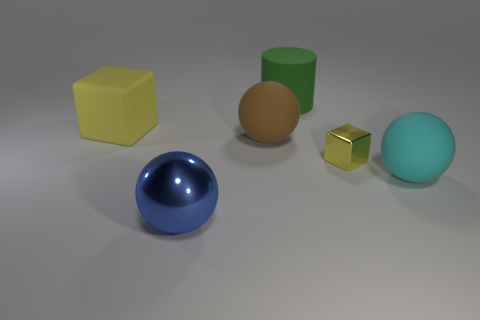Are there the same number of big balls that are behind the yellow matte object and blue metal things that are to the left of the blue ball?
Your response must be concise. Yes. There is a small thing that is the same color as the big rubber cube; what is it made of?
Ensure brevity in your answer.  Metal. There is a blue object that is the same size as the yellow rubber thing; what is its material?
Provide a succinct answer. Metal. Is the material of the big cyan thing the same as the big cylinder?
Your response must be concise. Yes. What color is the other thing that is the same material as the blue object?
Provide a succinct answer. Yellow. There is a blue thing that is the same shape as the big brown object; what material is it?
Your response must be concise. Metal. There is a thing that is in front of the shiny block and right of the big cylinder; what is it made of?
Provide a succinct answer. Rubber. The large brown thing that is the same material as the big cyan ball is what shape?
Provide a short and direct response. Sphere. There is a green cylinder that is the same material as the big cube; what is its size?
Your answer should be very brief. Large. There is a object that is both behind the big brown rubber thing and on the left side of the green thing; what shape is it?
Ensure brevity in your answer.  Cube. 